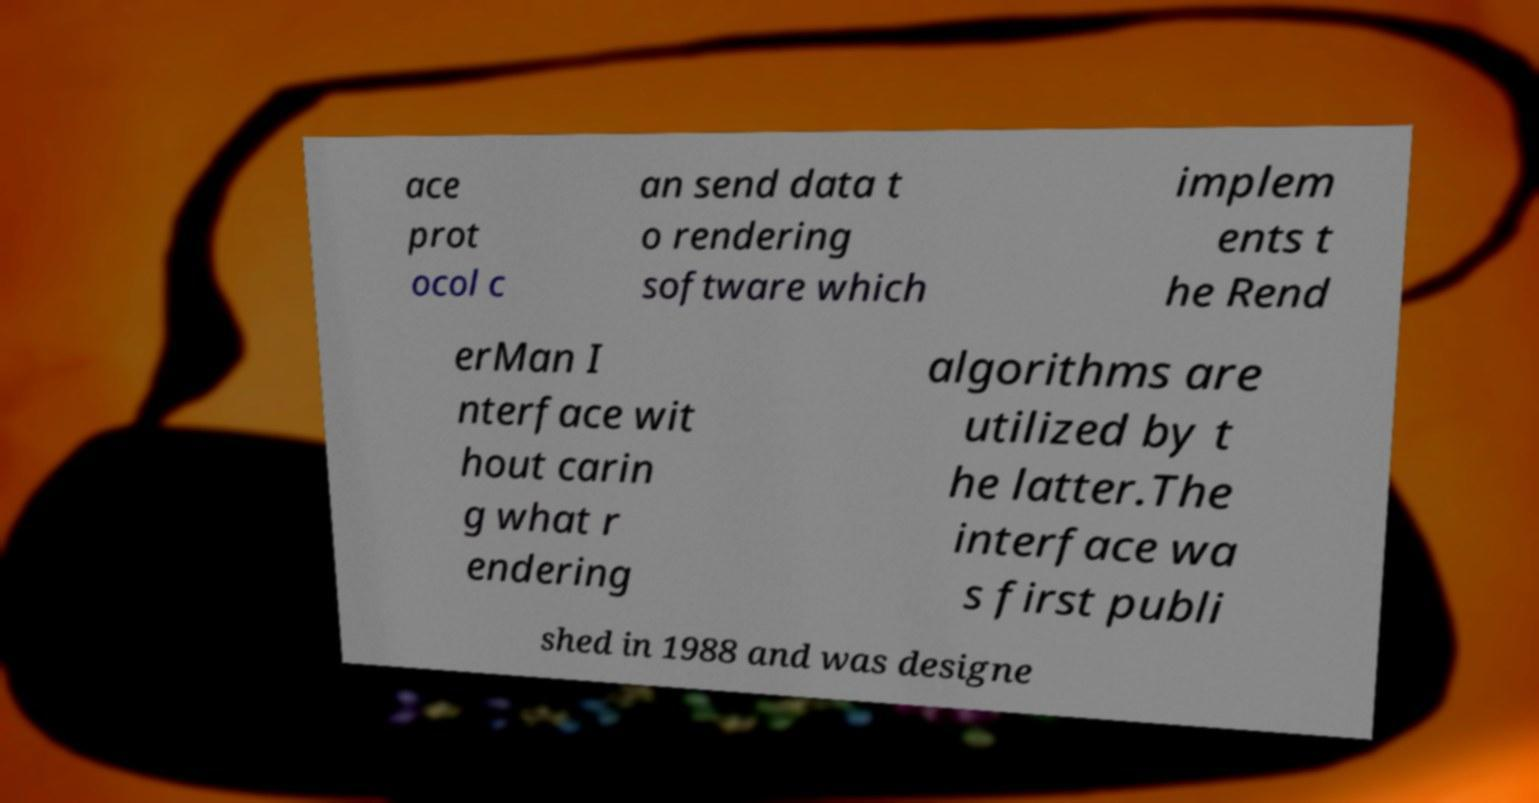What messages or text are displayed in this image? I need them in a readable, typed format. ace prot ocol c an send data t o rendering software which implem ents t he Rend erMan I nterface wit hout carin g what r endering algorithms are utilized by t he latter.The interface wa s first publi shed in 1988 and was designe 